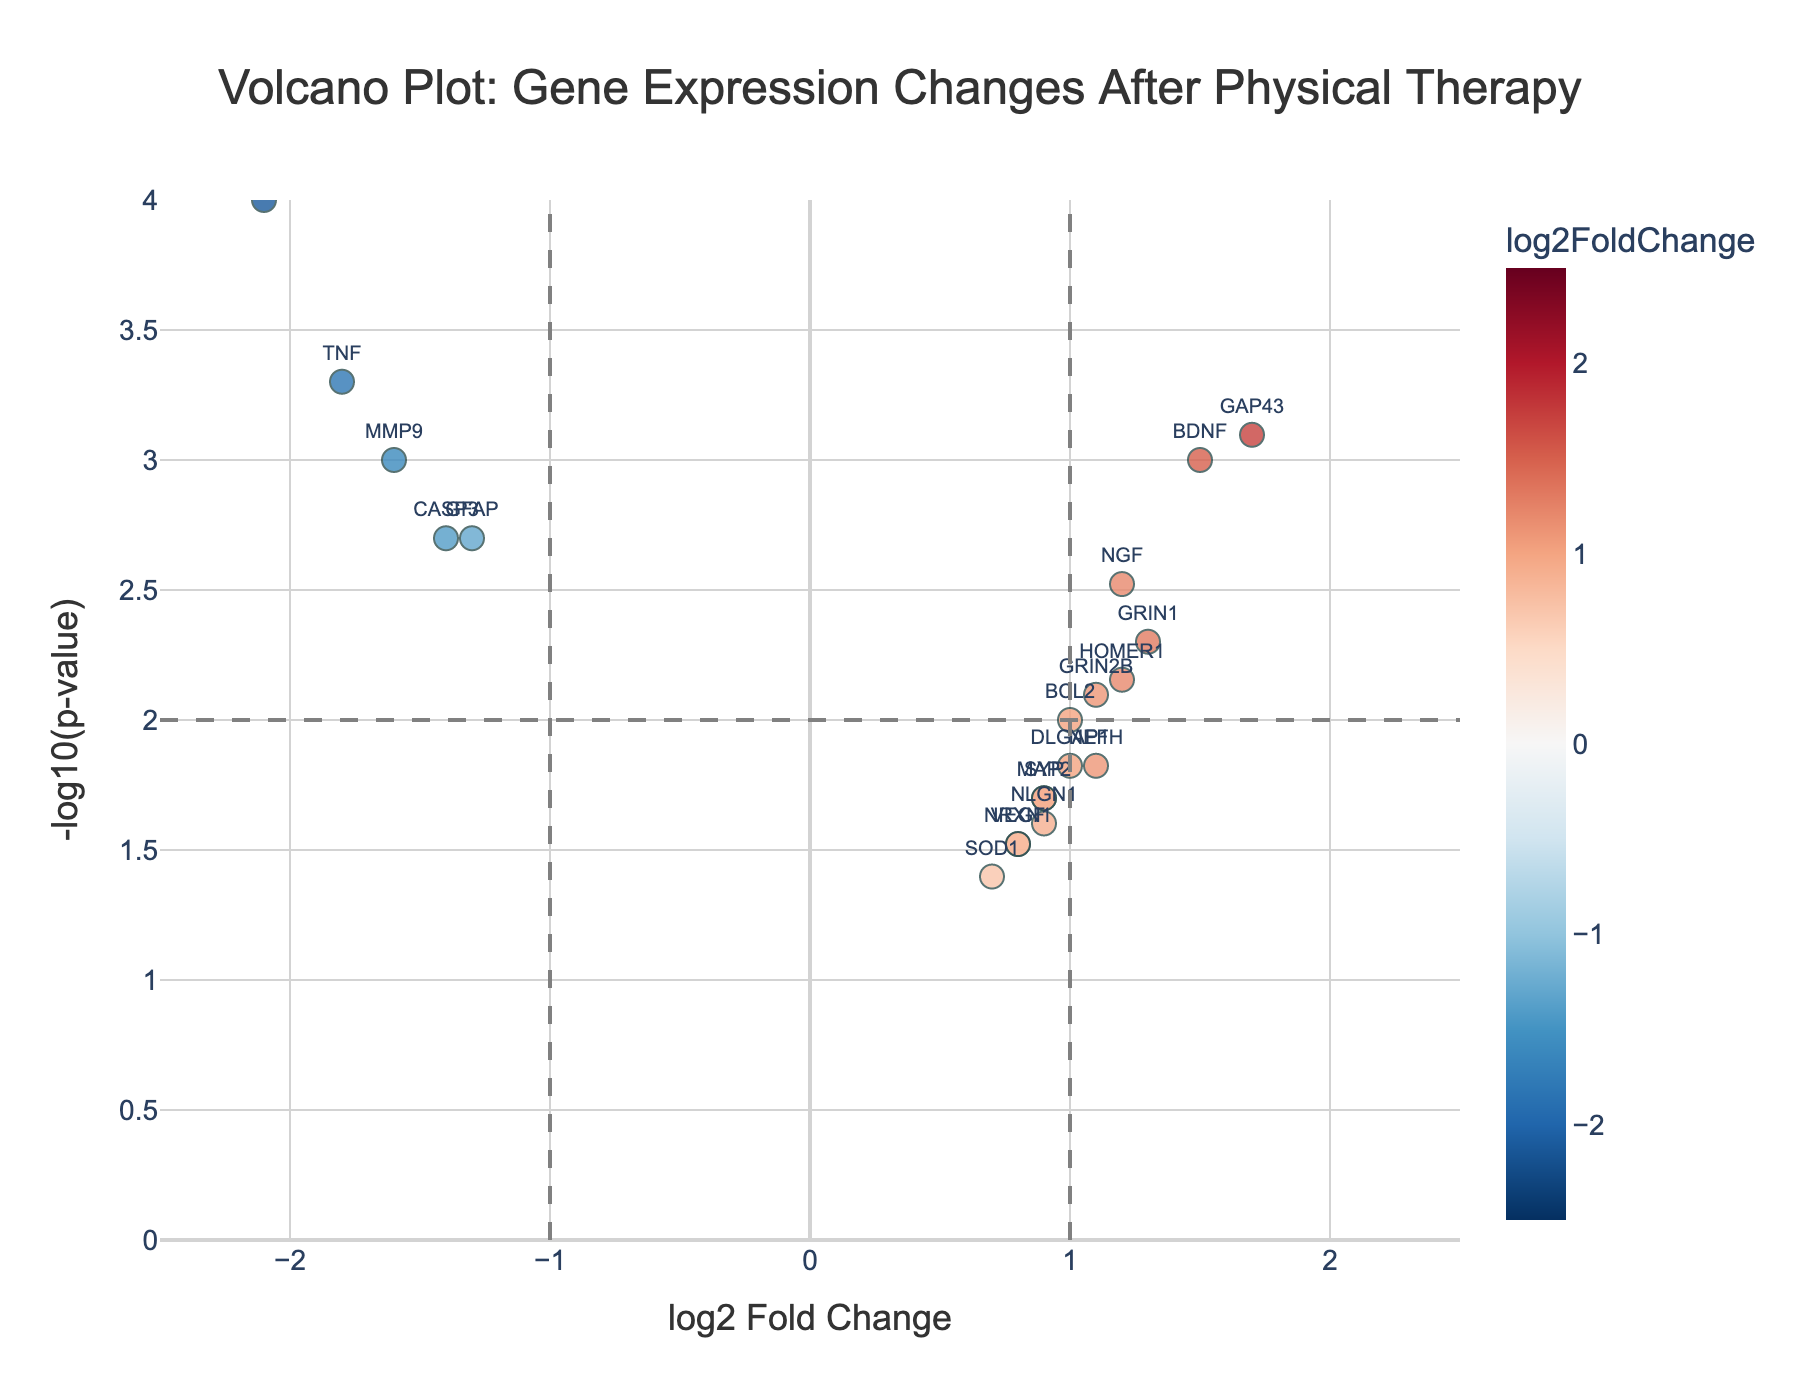What is the title of the volcano plot? The title is usually at the top of the plot and provides a brief description of the data being visualized. In this case, it would indicate the context of the gene expression changes due to physical therapy in spinal cord injury patients.
Answer: Volcano Plot: Gene Expression Changes After Physical Therapy Which gene has the highest -log10(p-value)? The highest -log10(p-value) indicates the gene with the most statistically significant change in expression. This is found at the topmost point of the plot.
Answer: IL6 How many genes show a log2FoldChange greater than 1.0? We need to count all the data points to the right of the vertical significance line placed at log2FoldChange = 1.
Answer: 8 Which gene has the highest log2FoldChange? This requires identifying the gene on the far right end of the horizontal axis, reflecting the most significant change in expression level.
Answer: GAP43 Among the genes with a log2FoldChange less than -1.0, which one has the lowest p-value? First, identify all the genes with log2FoldChange values less than -1.0. Then, among these, find the one at the highest point on the vertical axis, signifying the lowest p-value.
Answer: IL6 How does the expression of IL6 and BDNF differ? Compare the log2FoldChange for these genes. IL6 has a negative value indicating downregulation, while BDNF has a positive value indicating upregulation.
Answer: IL6 is downregulated, BDNF is upregulated Which gene is closest to the origin (0, 0)? Identify the data point closest to the center of the plot, where log2FoldChange and -log10(p-value) are both around zero.
Answer: VEGF What is the range of -log10(p-value) in the plot? This can be determined by examining the y-axis range. The lowest bound is typically above zero, and the highest value is the maximum point y-axis.
Answer: 0 to 4 Compare the expression changes for TNF and GRIN1. How do they differ? TNF is downregulated as it has a negative log2FoldChange, while GRIN1 is upregulated since it has a positive log2FoldChange.
Answer: TNF is downregulated, GRIN1 is upregulated Which gene has a log2FoldChange closest to zero and what does that signify? Identify the data point closest to the vertical line at log2FoldChange = 0. This signifies minimal change in gene expression.
Answer: VEGF, minimal change 